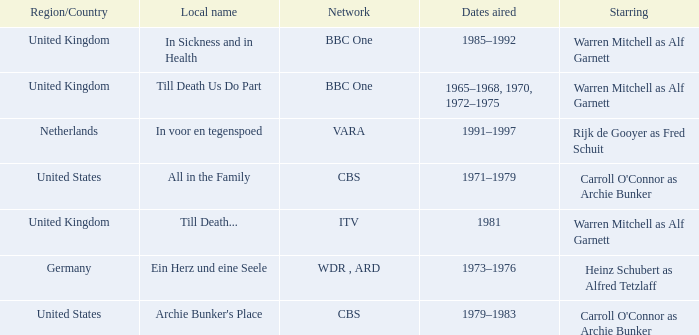Who was the star for the Vara network? Rijk de Gooyer as Fred Schuit. 